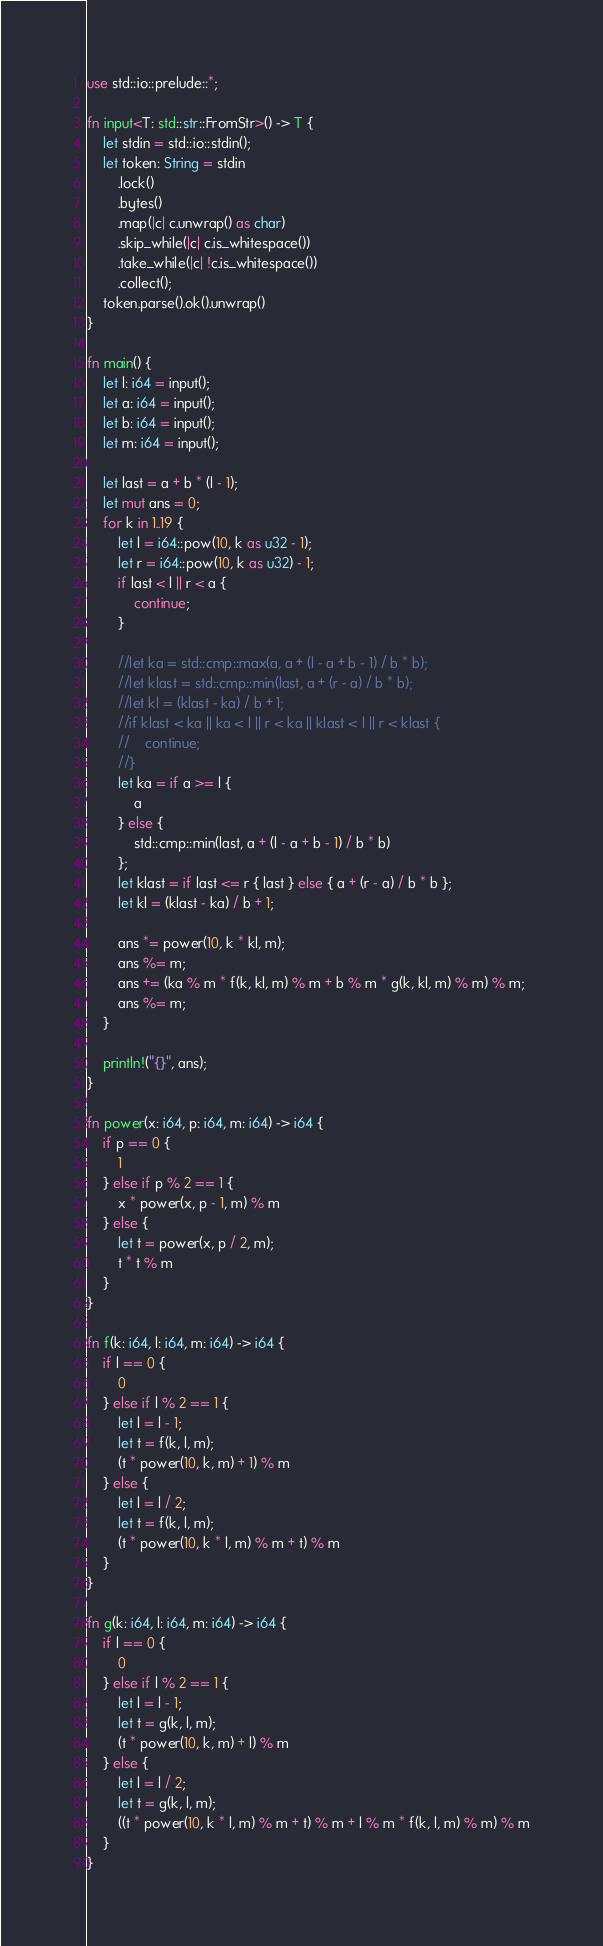<code> <loc_0><loc_0><loc_500><loc_500><_Rust_>use std::io::prelude::*;

fn input<T: std::str::FromStr>() -> T {
    let stdin = std::io::stdin();
    let token: String = stdin
        .lock()
        .bytes()
        .map(|c| c.unwrap() as char)
        .skip_while(|c| c.is_whitespace())
        .take_while(|c| !c.is_whitespace())
        .collect();
    token.parse().ok().unwrap()
}

fn main() {
    let l: i64 = input();
    let a: i64 = input();
    let b: i64 = input();
    let m: i64 = input();

    let last = a + b * (l - 1);
    let mut ans = 0;
    for k in 1..19 {
        let l = i64::pow(10, k as u32 - 1);
        let r = i64::pow(10, k as u32) - 1;
        if last < l || r < a {
            continue;
        }

        //let ka = std::cmp::max(a, a + (l - a + b - 1) / b * b);
        //let klast = std::cmp::min(last, a + (r - a) / b * b);
        //let kl = (klast - ka) / b + 1;
        //if klast < ka || ka < l || r < ka || klast < l || r < klast {
        //    continue;
        //}
        let ka = if a >= l {
            a
        } else {
            std::cmp::min(last, a + (l - a + b - 1) / b * b)
        };
        let klast = if last <= r { last } else { a + (r - a) / b * b };
        let kl = (klast - ka) / b + 1;

        ans *= power(10, k * kl, m);
        ans %= m;
        ans += (ka % m * f(k, kl, m) % m + b % m * g(k, kl, m) % m) % m;
        ans %= m;
    }

    println!("{}", ans);
}

fn power(x: i64, p: i64, m: i64) -> i64 {
    if p == 0 {
        1
    } else if p % 2 == 1 {
        x * power(x, p - 1, m) % m
    } else {
        let t = power(x, p / 2, m);
        t * t % m
    }
}

fn f(k: i64, l: i64, m: i64) -> i64 {
    if l == 0 {
        0
    } else if l % 2 == 1 {
        let l = l - 1;
        let t = f(k, l, m);
        (t * power(10, k, m) + 1) % m
    } else {
        let l = l / 2;
        let t = f(k, l, m);
        (t * power(10, k * l, m) % m + t) % m
    }
}

fn g(k: i64, l: i64, m: i64) -> i64 {
    if l == 0 {
        0
    } else if l % 2 == 1 {
        let l = l - 1;
        let t = g(k, l, m);
        (t * power(10, k, m) + l) % m
    } else {
        let l = l / 2;
        let t = g(k, l, m);
        ((t * power(10, k * l, m) % m + t) % m + l % m * f(k, l, m) % m) % m
    }
}
</code> 